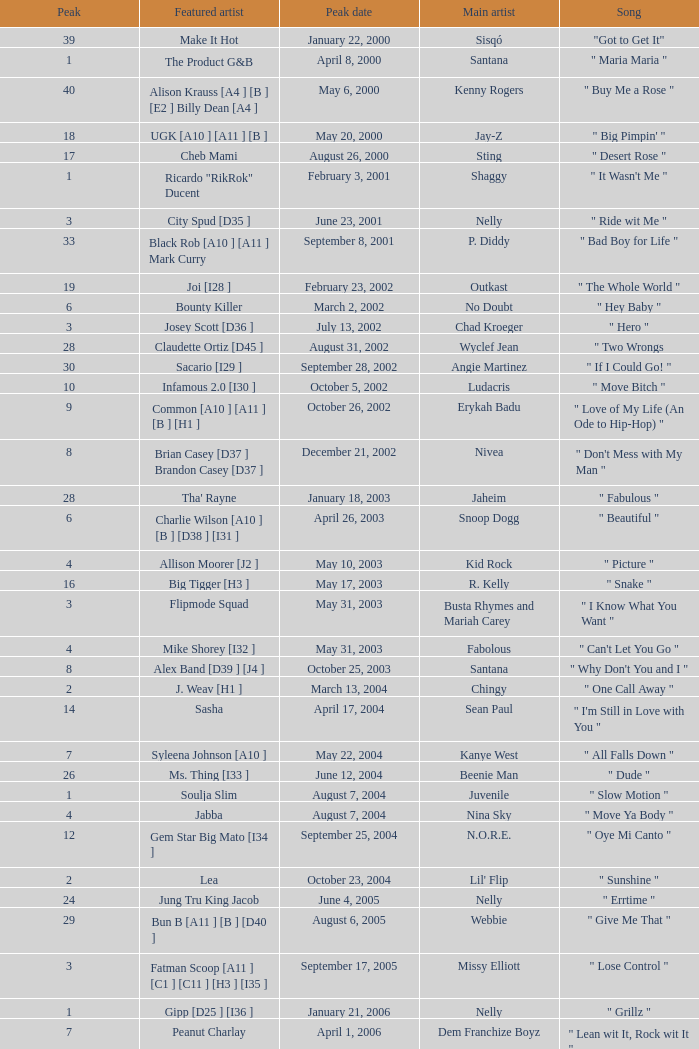What was the peak date of Kelis's song? August 6, 2006. 